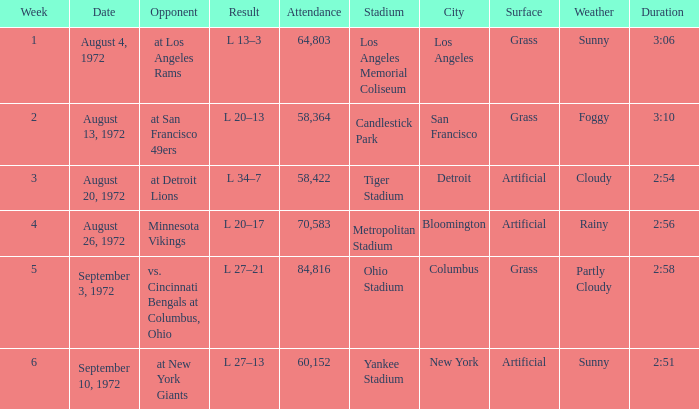How many weeks had an attendance larger than 84,816? 0.0. 